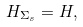Convert formula to latex. <formula><loc_0><loc_0><loc_500><loc_500>H _ { \Sigma _ { s } } = H ,</formula> 